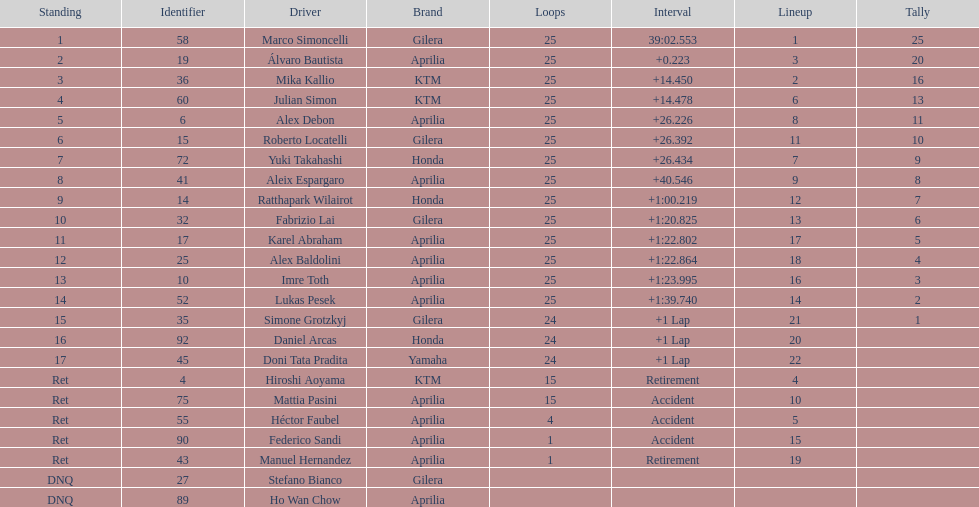Who perfomed the most number of laps, marco simoncelli or hiroshi aoyama? Marco Simoncelli. 